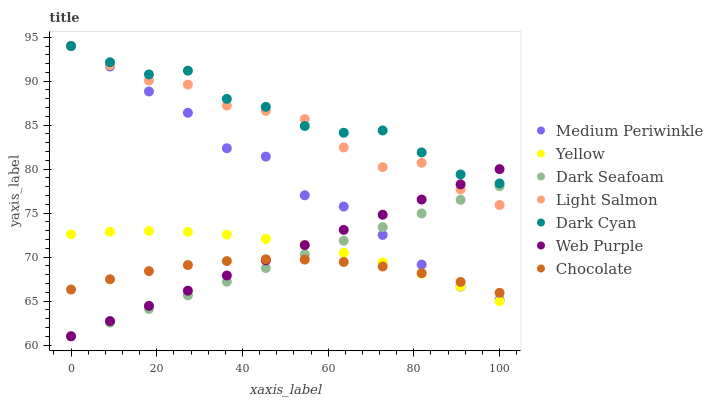Does Chocolate have the minimum area under the curve?
Answer yes or no. Yes. Does Dark Cyan have the maximum area under the curve?
Answer yes or no. Yes. Does Medium Periwinkle have the minimum area under the curve?
Answer yes or no. No. Does Medium Periwinkle have the maximum area under the curve?
Answer yes or no. No. Is Dark Seafoam the smoothest?
Answer yes or no. Yes. Is Light Salmon the roughest?
Answer yes or no. Yes. Is Medium Periwinkle the smoothest?
Answer yes or no. No. Is Medium Periwinkle the roughest?
Answer yes or no. No. Does Dark Seafoam have the lowest value?
Answer yes or no. Yes. Does Medium Periwinkle have the lowest value?
Answer yes or no. No. Does Dark Cyan have the highest value?
Answer yes or no. Yes. Does Dark Seafoam have the highest value?
Answer yes or no. No. Is Dark Seafoam less than Dark Cyan?
Answer yes or no. Yes. Is Light Salmon greater than Yellow?
Answer yes or no. Yes. Does Light Salmon intersect Dark Seafoam?
Answer yes or no. Yes. Is Light Salmon less than Dark Seafoam?
Answer yes or no. No. Is Light Salmon greater than Dark Seafoam?
Answer yes or no. No. Does Dark Seafoam intersect Dark Cyan?
Answer yes or no. No. 